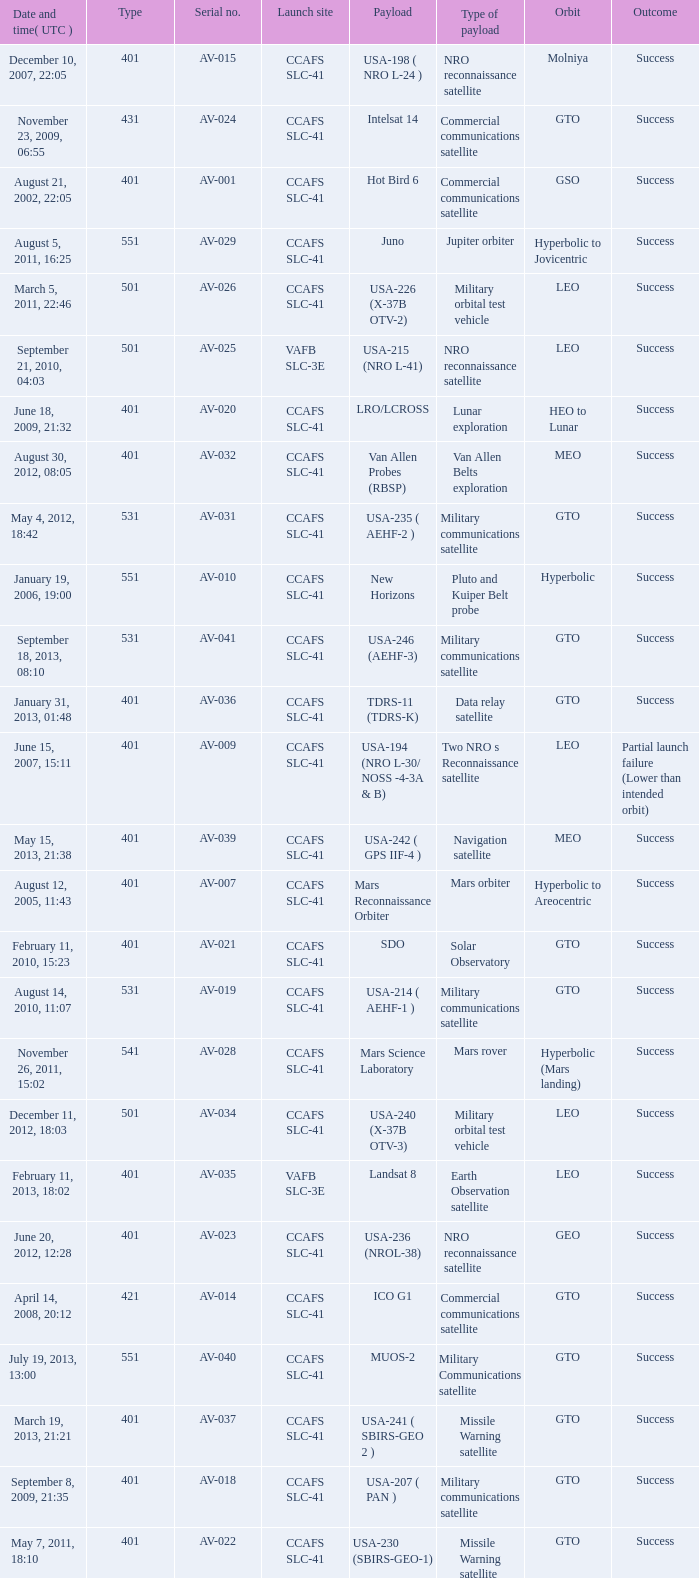For the payload of Van Allen Belts Exploration what's the serial number? AV-032. 